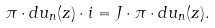Convert formula to latex. <formula><loc_0><loc_0><loc_500><loc_500>\pi \cdot d u _ { n } ( z ) \cdot i = J \cdot \pi \cdot d u _ { n } ( z ) .</formula> 